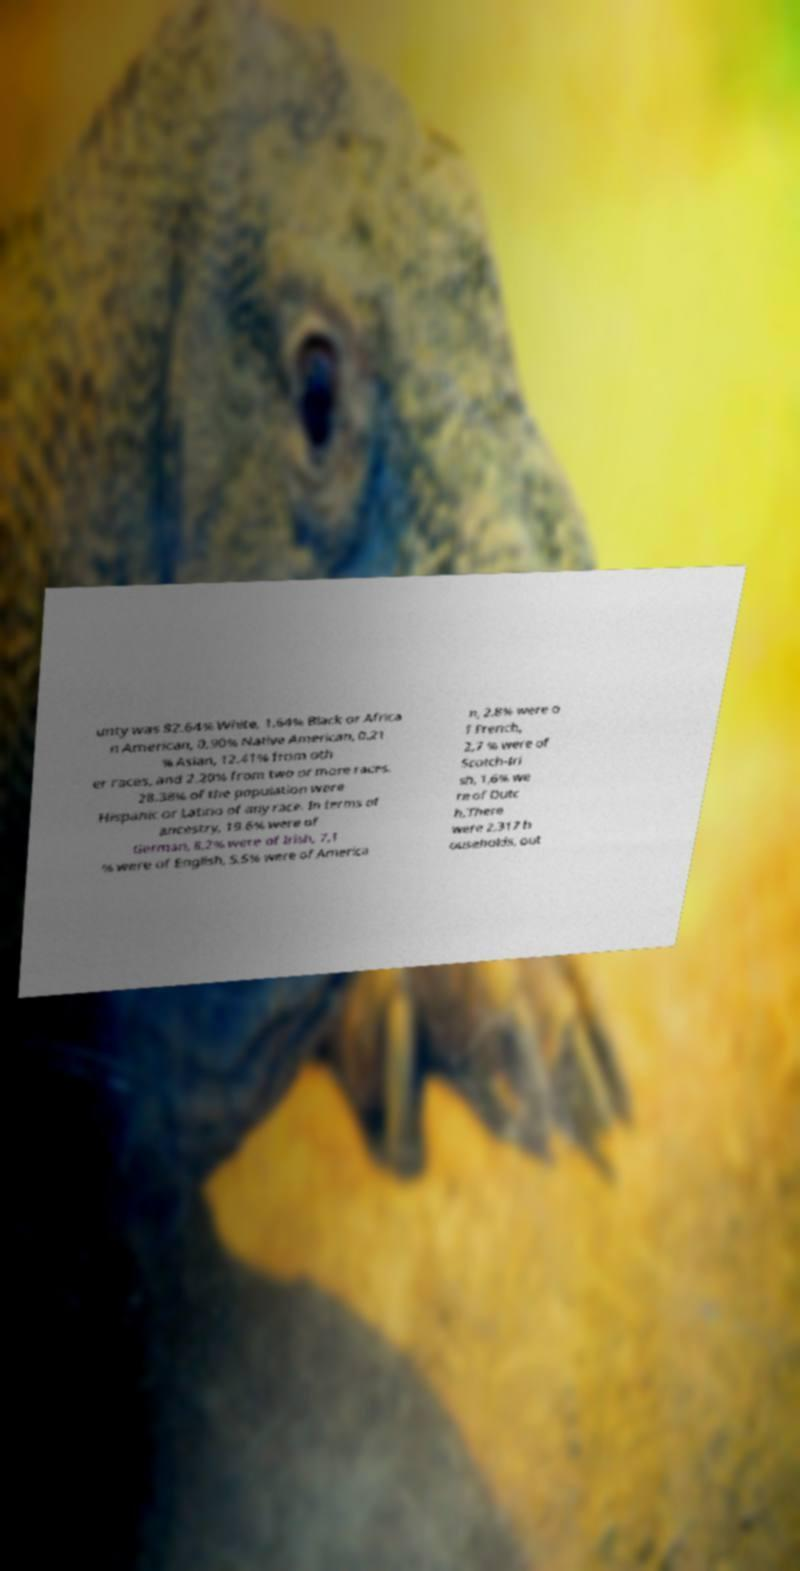Can you read and provide the text displayed in the image?This photo seems to have some interesting text. Can you extract and type it out for me? unty was 82.64% White, 1.64% Black or Africa n American, 0.90% Native American, 0.21 % Asian, 12.41% from oth er races, and 2.20% from two or more races. 28.38% of the population were Hispanic or Latino of any race. In terms of ancestry, 19.6% were of German, 8,2% were of Irish, 7,1 % were of English, 5,5% were of America n, 2,8% were o f French, 2,7 % were of Scotch-Iri sh, 1,6% we re of Dutc h.There were 2,317 h ouseholds, out 